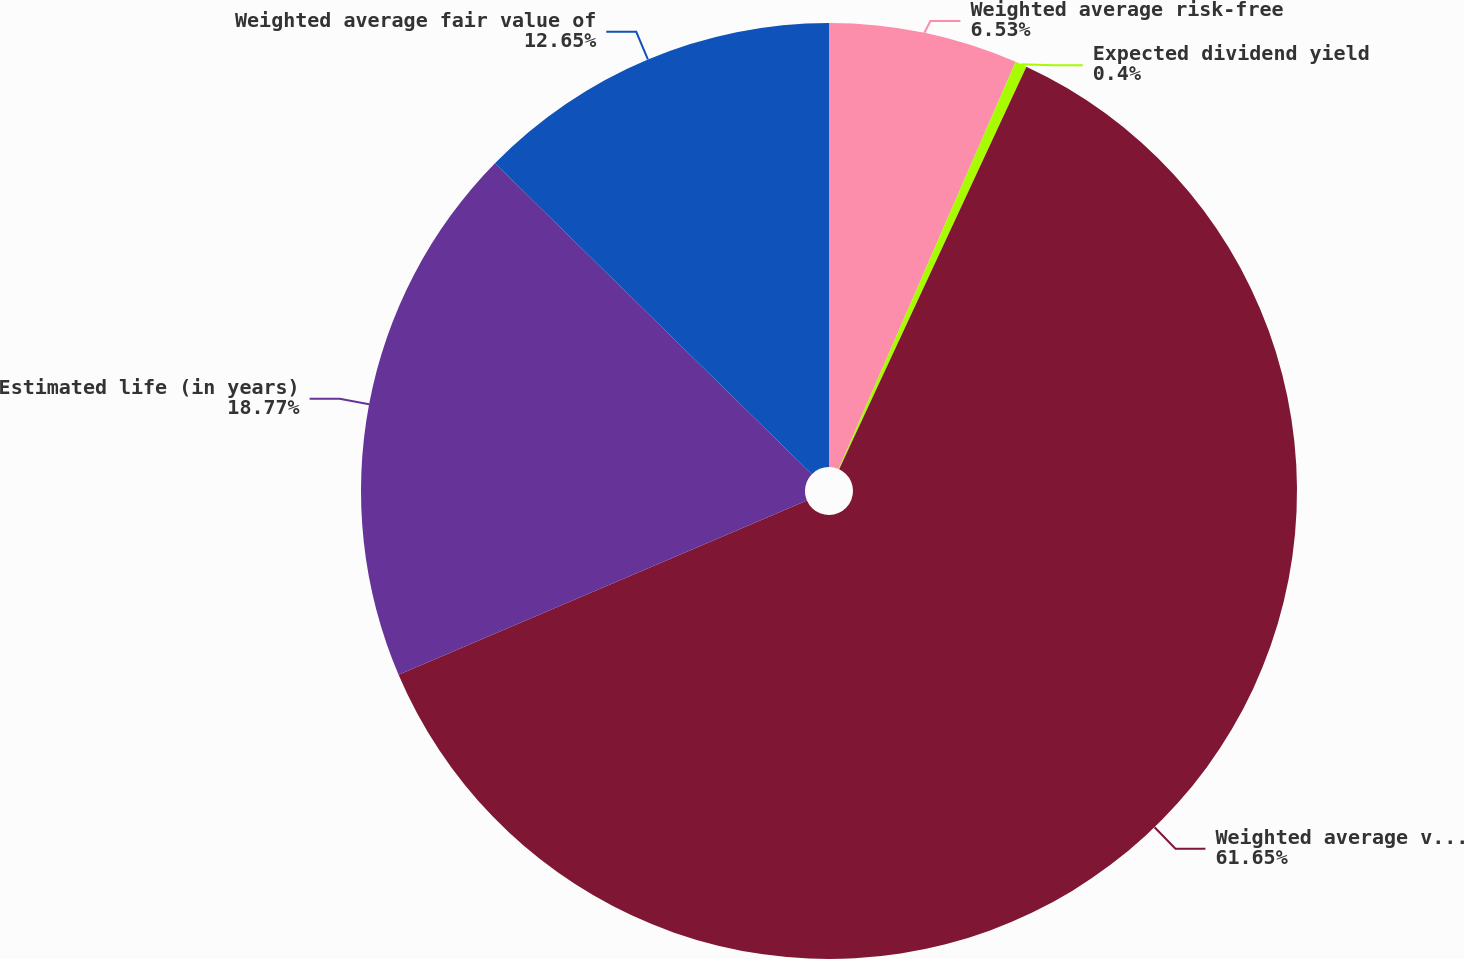Convert chart to OTSL. <chart><loc_0><loc_0><loc_500><loc_500><pie_chart><fcel>Weighted average risk-free<fcel>Expected dividend yield<fcel>Weighted average volatility<fcel>Estimated life (in years)<fcel>Weighted average fair value of<nl><fcel>6.53%<fcel>0.4%<fcel>61.65%<fcel>18.77%<fcel>12.65%<nl></chart> 